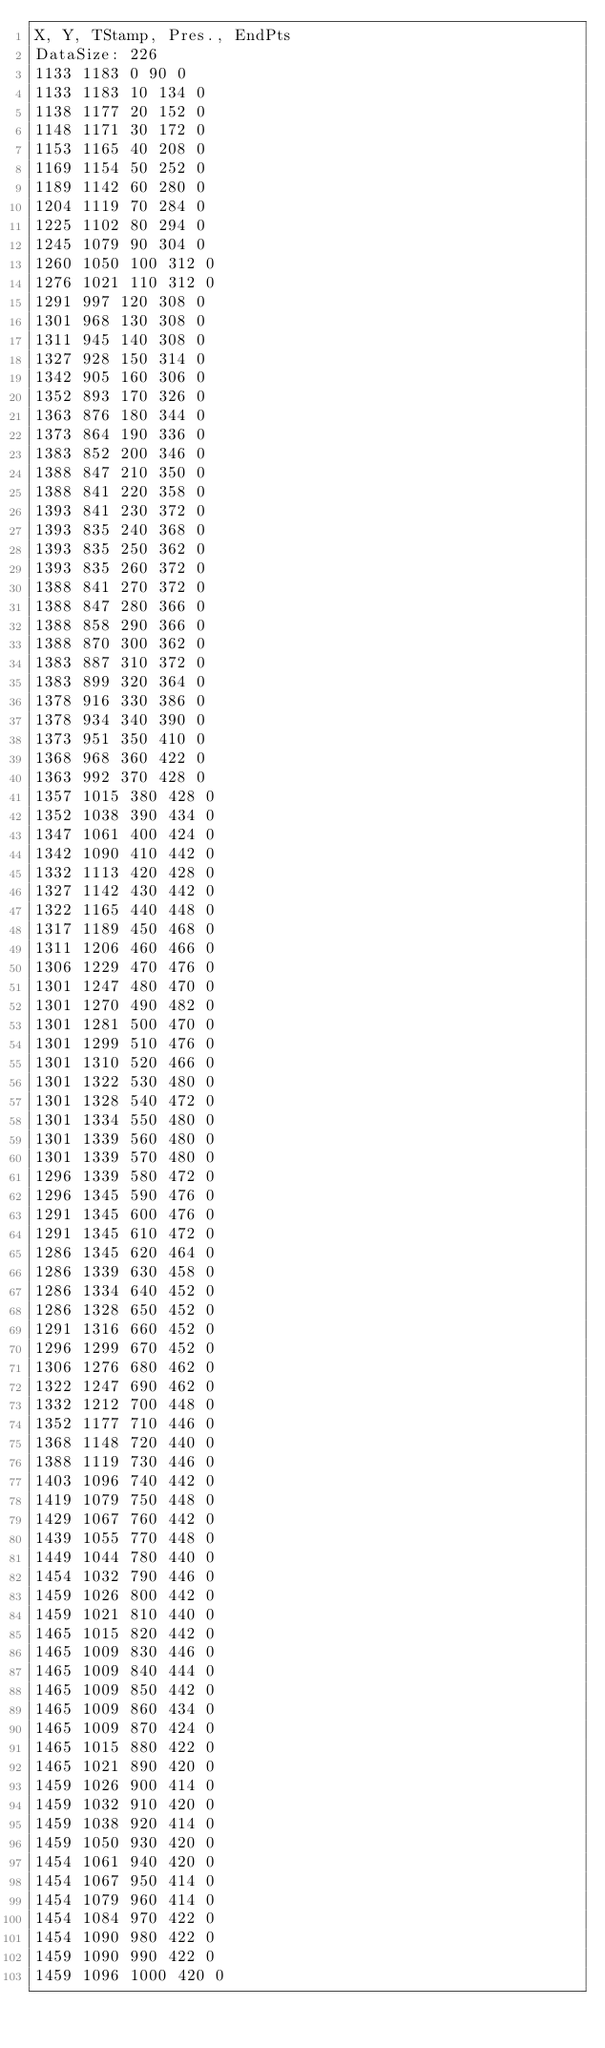<code> <loc_0><loc_0><loc_500><loc_500><_SML_>X, Y, TStamp, Pres., EndPts
DataSize: 226
1133 1183 0 90 0
1133 1183 10 134 0
1138 1177 20 152 0
1148 1171 30 172 0
1153 1165 40 208 0
1169 1154 50 252 0
1189 1142 60 280 0
1204 1119 70 284 0
1225 1102 80 294 0
1245 1079 90 304 0
1260 1050 100 312 0
1276 1021 110 312 0
1291 997 120 308 0
1301 968 130 308 0
1311 945 140 308 0
1327 928 150 314 0
1342 905 160 306 0
1352 893 170 326 0
1363 876 180 344 0
1373 864 190 336 0
1383 852 200 346 0
1388 847 210 350 0
1388 841 220 358 0
1393 841 230 372 0
1393 835 240 368 0
1393 835 250 362 0
1393 835 260 372 0
1388 841 270 372 0
1388 847 280 366 0
1388 858 290 366 0
1388 870 300 362 0
1383 887 310 372 0
1383 899 320 364 0
1378 916 330 386 0
1378 934 340 390 0
1373 951 350 410 0
1368 968 360 422 0
1363 992 370 428 0
1357 1015 380 428 0
1352 1038 390 434 0
1347 1061 400 424 0
1342 1090 410 442 0
1332 1113 420 428 0
1327 1142 430 442 0
1322 1165 440 448 0
1317 1189 450 468 0
1311 1206 460 466 0
1306 1229 470 476 0
1301 1247 480 470 0
1301 1270 490 482 0
1301 1281 500 470 0
1301 1299 510 476 0
1301 1310 520 466 0
1301 1322 530 480 0
1301 1328 540 472 0
1301 1334 550 480 0
1301 1339 560 480 0
1301 1339 570 480 0
1296 1339 580 472 0
1296 1345 590 476 0
1291 1345 600 476 0
1291 1345 610 472 0
1286 1345 620 464 0
1286 1339 630 458 0
1286 1334 640 452 0
1286 1328 650 452 0
1291 1316 660 452 0
1296 1299 670 452 0
1306 1276 680 462 0
1322 1247 690 462 0
1332 1212 700 448 0
1352 1177 710 446 0
1368 1148 720 440 0
1388 1119 730 446 0
1403 1096 740 442 0
1419 1079 750 448 0
1429 1067 760 442 0
1439 1055 770 448 0
1449 1044 780 440 0
1454 1032 790 446 0
1459 1026 800 442 0
1459 1021 810 440 0
1465 1015 820 442 0
1465 1009 830 446 0
1465 1009 840 444 0
1465 1009 850 442 0
1465 1009 860 434 0
1465 1009 870 424 0
1465 1015 880 422 0
1465 1021 890 420 0
1459 1026 900 414 0
1459 1032 910 420 0
1459 1038 920 414 0
1459 1050 930 420 0
1454 1061 940 420 0
1454 1067 950 414 0
1454 1079 960 414 0
1454 1084 970 422 0
1454 1090 980 422 0
1459 1090 990 422 0
1459 1096 1000 420 0</code> 